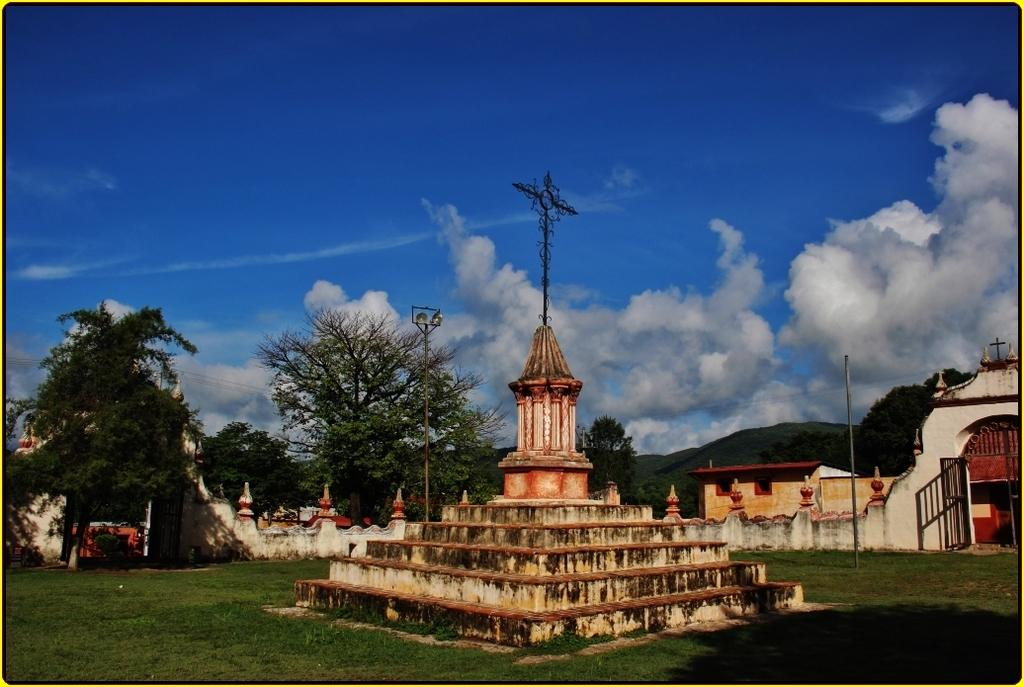What color is the sky in the image? The sky is blue in the image. What can be seen in the sky besides the blue color? There are clouds in the image. What is visible in the background of the image? There is a building and trees in the background of the image. What symbol is present in the image? There is a cross symbol in the image. What architectural feature can be seen in the image? There are steps in the image. What type of vegetation covers the land in the image? The land is covered with grass. What type of structure is present in the image for illumination? There is a light pole in the image. How many wrens are perched on the light pole in the image? There are no wrens present in the image; the light pole is the only structure visible for illumination. 